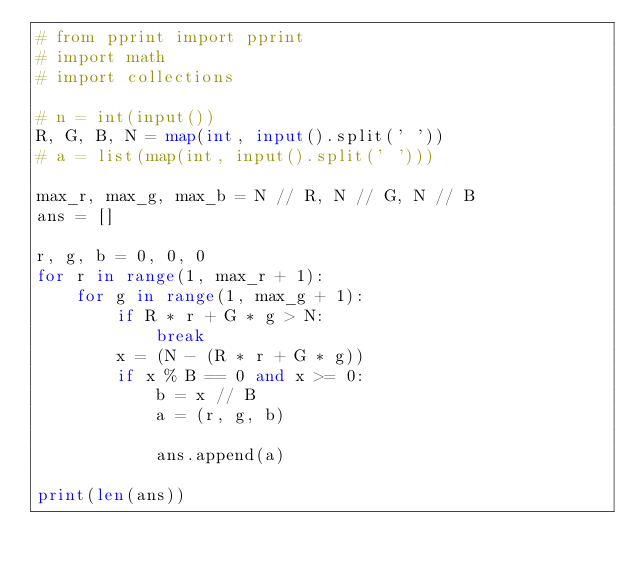<code> <loc_0><loc_0><loc_500><loc_500><_Python_># from pprint import pprint
# import math
# import collections

# n = int(input())
R, G, B, N = map(int, input().split(' '))
# a = list(map(int, input().split(' ')))

max_r, max_g, max_b = N // R, N // G, N // B
ans = []

r, g, b = 0, 0, 0
for r in range(1, max_r + 1):
    for g in range(1, max_g + 1):
        if R * r + G * g > N:
            break
        x = (N - (R * r + G * g))
        if x % B == 0 and x >= 0:
            b = x // B
            a = (r, g, b)

            ans.append(a)

print(len(ans))
</code> 